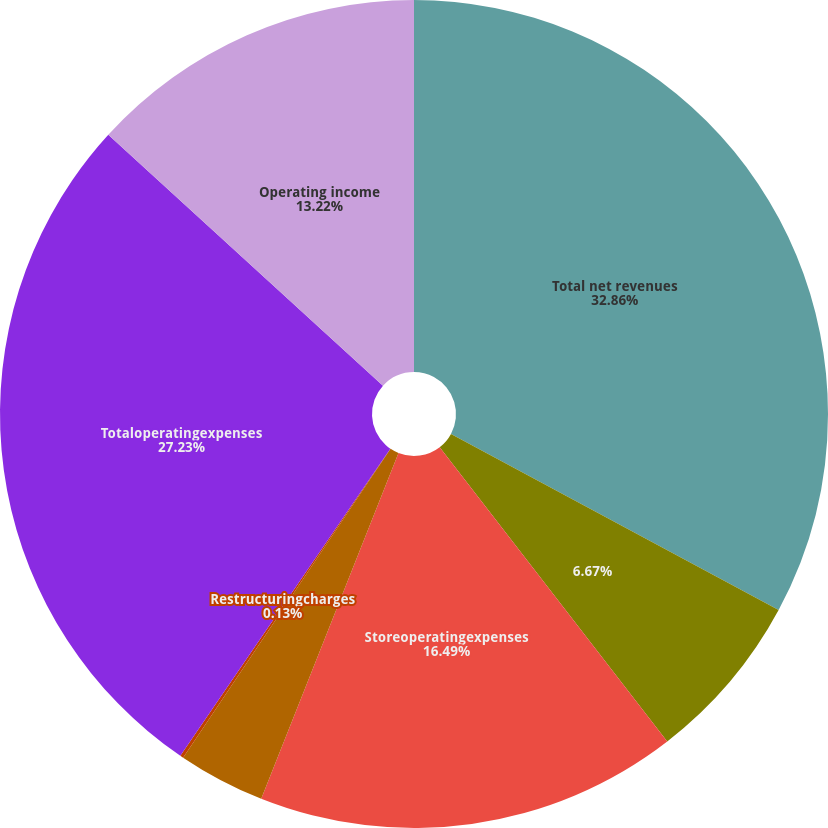<chart> <loc_0><loc_0><loc_500><loc_500><pie_chart><fcel>Total net revenues<fcel>Unnamed: 1<fcel>Storeoperatingexpenses<fcel>Otheroperatingexpenses<fcel>Restructuringcharges<fcel>Totaloperatingexpenses<fcel>Operating income<nl><fcel>32.85%<fcel>6.67%<fcel>16.49%<fcel>3.4%<fcel>0.13%<fcel>27.23%<fcel>13.22%<nl></chart> 